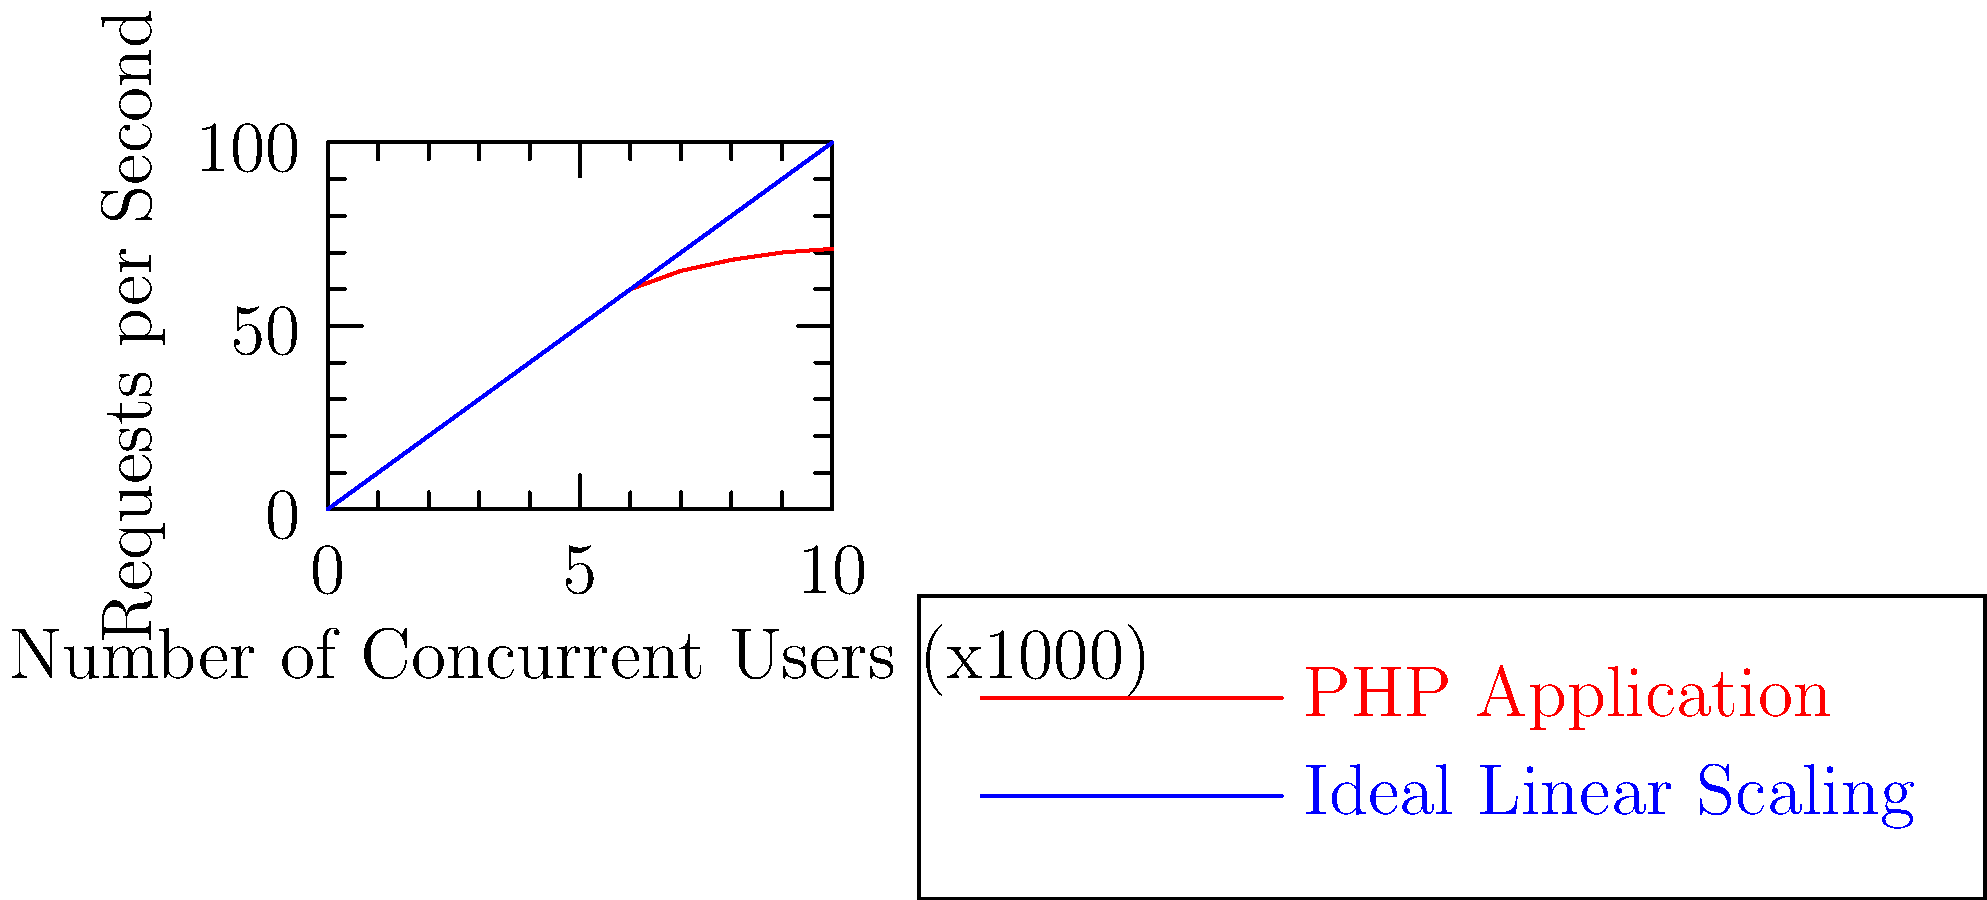Analisando o gráfico de desempenho de uma aplicação PHP sob carga, qual é o principal problema de escalabilidade evidenciado e como isso poderia ser mitigado usando recursos avançados do PHP ou práticas de arquitetura de software? Para analisar este problema de escalabilidade e propor soluções, vamos seguir os seguintes passos:

1. Identificação do problema:
   O gráfico mostra que a aplicação PHP (linha vermelha) não escala linearmente com o aumento de usuários concorrentes, diferentemente do cenário ideal (linha azul).

2. Causa provável:
   Este comportamento geralmente indica gargalos de recursos, como:
   - Sobrecarga do servidor web
   - Limitações de conexões de banco de dados
   - Uso excessivo de memória ou CPU

3. Soluções usando recursos avançados do PHP:
   a) Implementar cache:
      - Utilizar APC (Alternative PHP Cache) ou OPcache para cache de bytecode
      - Usar Memcached ou Redis para cache de dados

   b) Otimizar consultas ao banco de dados:
      - Implementar lazy loading com ORM avançados como Doctrine
      - Utilizar prepared statements para melhorar a performance das queries

   c) Gerenciamento eficiente de recursos:
      - Usar generators para processar grandes conjuntos de dados com baixo consumo de memória
      - Implementar Fibers (PHP 8.1+) para concorrência cooperativa

4. Práticas de arquitetura de software:
   a) Implementar uma arquitetura de microserviços:
      - Dividir a aplicação em serviços menores e independentes
      - Utilizar filas de mensagens (ex: RabbitMQ) para processamento assíncrono

   b) Adotar uma estratégia de cache distribuído:
      - Implementar CDN para conteúdo estático
      - Utilizar Varnish como cache de página completa

   c) Otimizar o balanceamento de carga:
      - Implementar um load balancer mais eficiente (ex: Nginx)
      - Utilizar sticky sessions para melhorar o cache local

5. Monitoramento e ajuste contínuo:
   - Implementar ferramentas de profiling como Xdebug ou Blackfire
   - Realizar testes de carga regulares e ajustar a infraestrutura conforme necessário

Ao aplicar estas técnicas, é possível melhorar significativamente a escalabilidade da aplicação PHP, aproximando-a do cenário ideal de escalabilidade linear.
Answer: Problema: Escalabilidade não-linear. Soluções: Implementar caching eficiente, otimizar queries, usar generators/fibers, adotar microserviços, balanceamento de carga e monitoramento contínuo. 